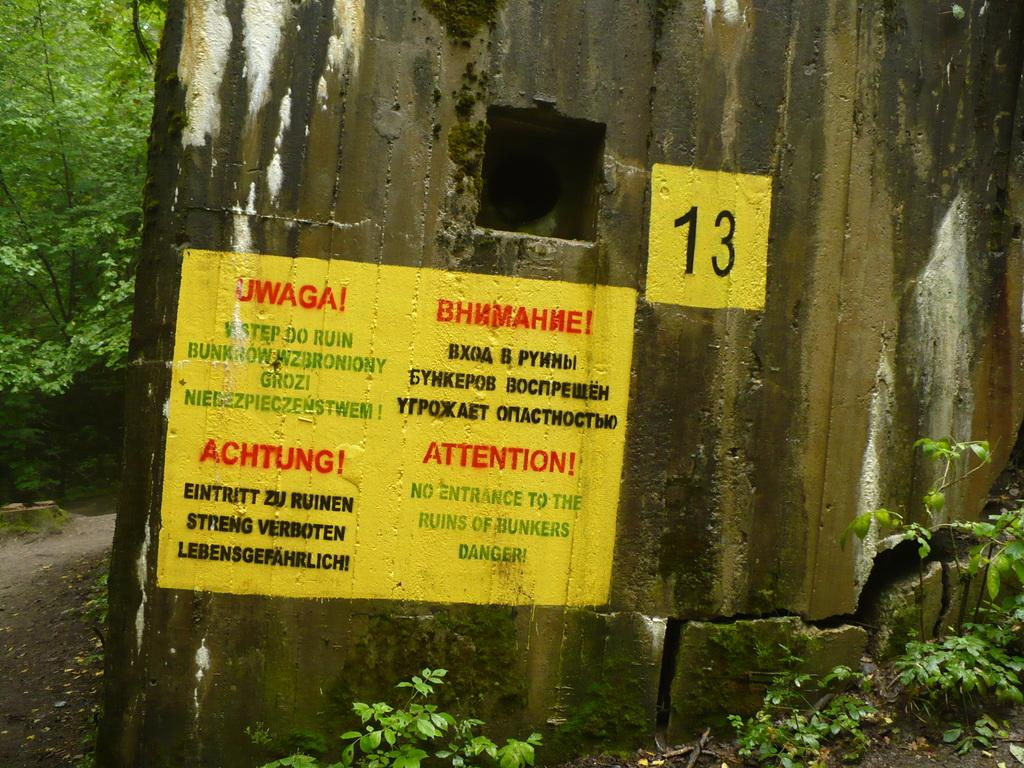What is present on the wall in the image? There is a painting with text on the wall. What else can be seen on the wall? There is a wall in the image. What type of vegetation is visible in the image? There are plants and trees visible in the image. What type of tree is visible in the cellar in the image? There is no cellar present in the image, and therefore no tree can be found in a cellar. 